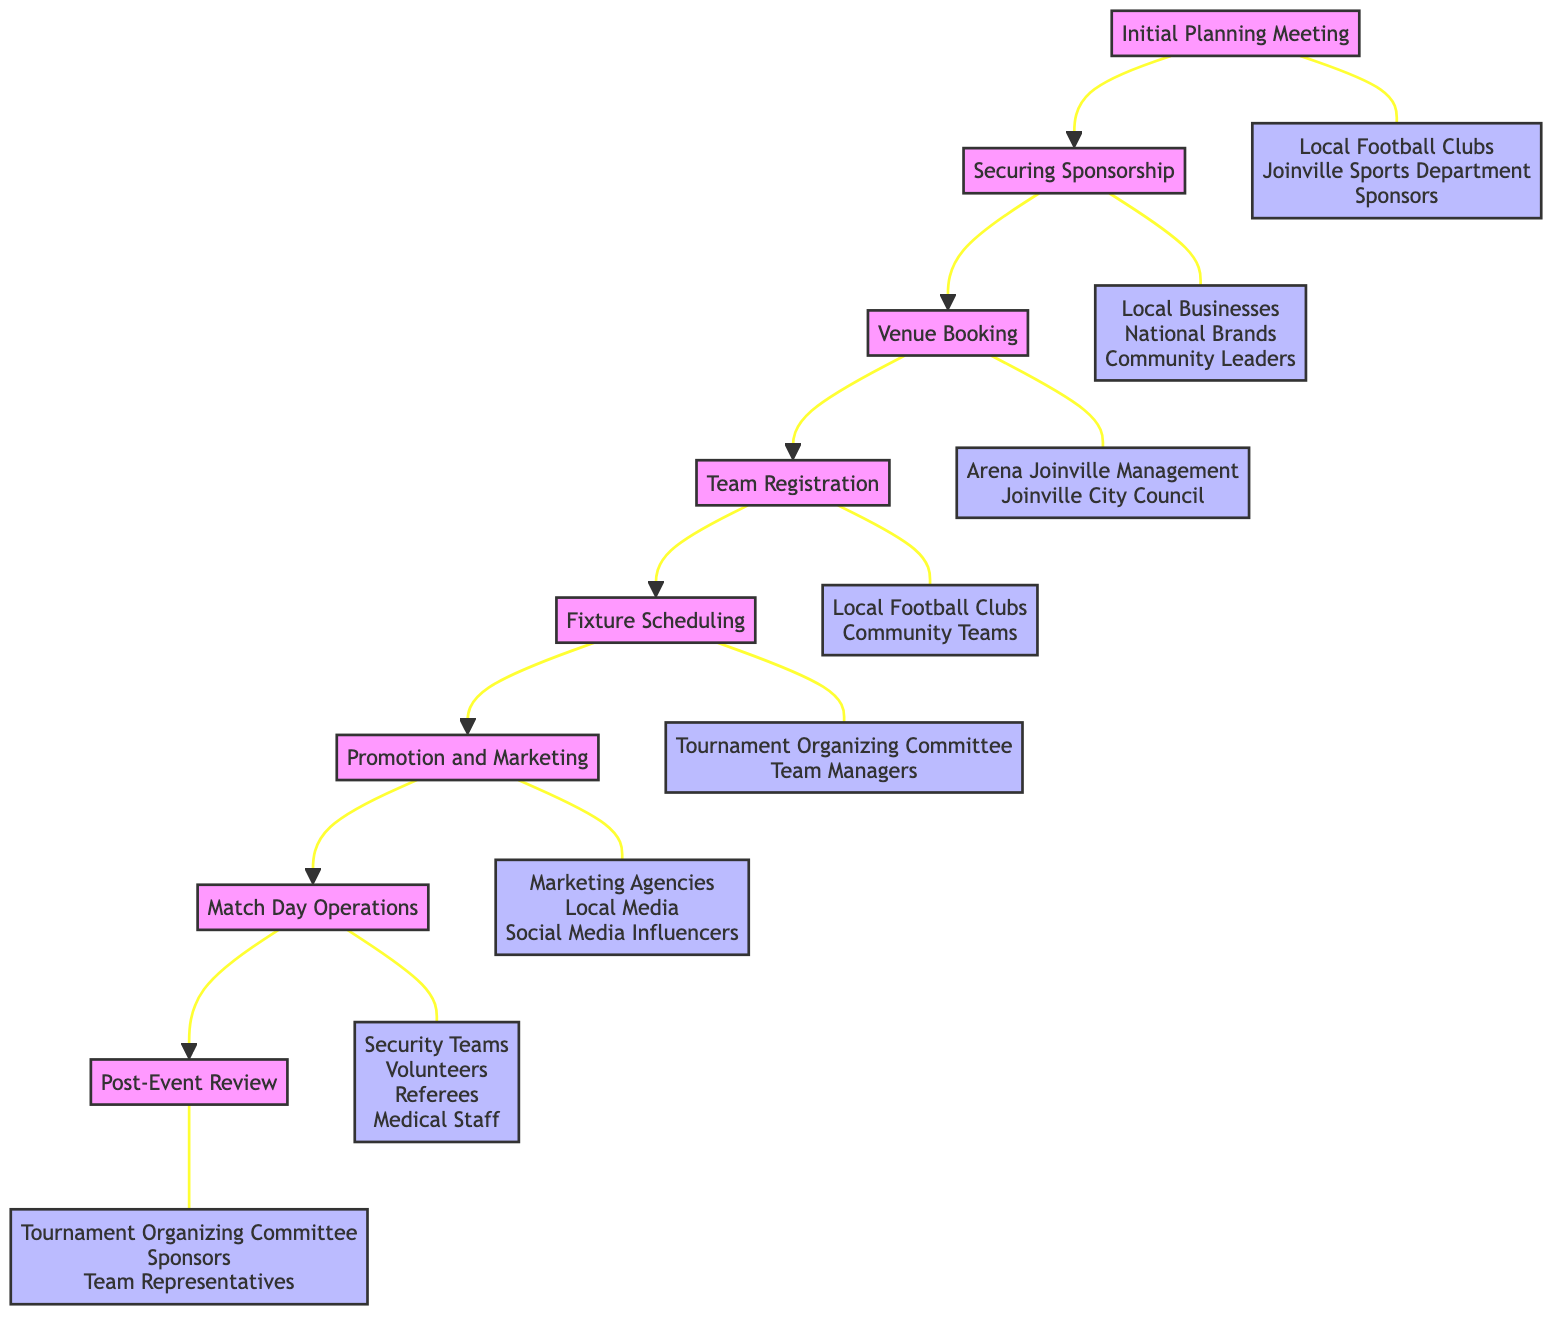What is the first step in the tournament organization process? The diagram indicates that the first step is "Initial Planning Meeting". It is the starting point of the flow chart and connects directly to the second step.
Answer: Initial Planning Meeting How many stakeholders are involved in the 'Match Day Operations' step? Referring to the 'Match Day Operations' step, it lists four stakeholders: Security Teams, Volunteers, Referees, and Medical Staff. Counting these stakeholders gives a total of four.
Answer: 4 Which step follows 'Fixture Scheduling'? From the flow chart, 'Fixture Scheduling' is followed directly by 'Promotion and Marketing'. There’s a clear arrow indicating this progression.
Answer: Promotion and Marketing Who are the stakeholders involved in 'Venue Booking'? The 'Venue Booking' step includes two stakeholders: Arena Joinville Management and Joinville City Council. This information can be found by checking the associated stakeholder node for this step.
Answer: Arena Joinville Management, Joinville City Council What is the last step in the tournament organization process? Looking at the flow chart, the last step in the sequence is 'Post-Event Review', which follows all prior steps in the organization process.
Answer: Post-Event Review How many total steps are there in the tournament organization process? The flow chart contains eight distinct steps that outline the organization process from beginning to end. By counting each labeled step, I reach the total of eight.
Answer: 8 Which two steps are directly connected by a flow line in the diagram? Analyzing the flow chart, 'Securing Sponsorship' and 'Venue Booking' are directly connected by an arrow. This visual connection illustrates the sequence of steps in organizing the tournament.
Answer: Securing Sponsorship, Venue Booking What types of organizations are targeted for sponsorship in the tournament? The stakeholders involved in 'Securing Sponsorship' include Local Businesses, National Brands, and Community Leaders. This information is specifically listed in the stakeholder section of that step.
Answer: Local Businesses, National Brands, Community Leaders 